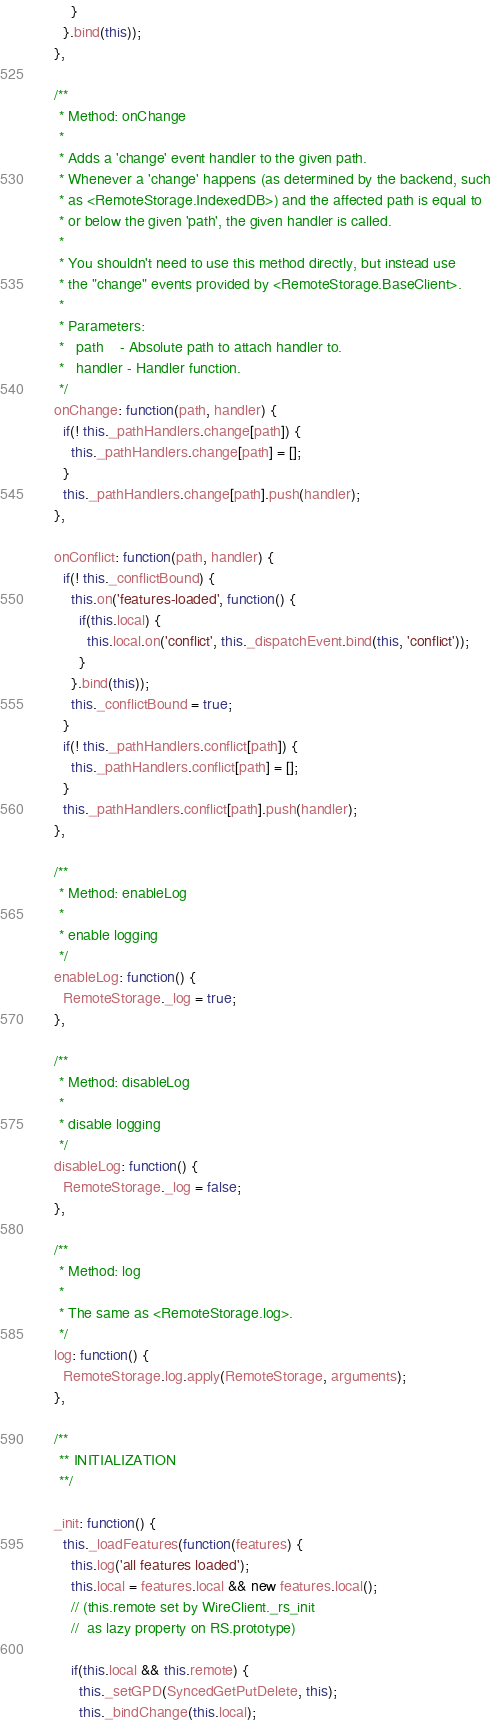Convert code to text. <code><loc_0><loc_0><loc_500><loc_500><_JavaScript_>        }
      }.bind(this));
    },

    /**
     * Method: onChange
     *
     * Adds a 'change' event handler to the given path.
     * Whenever a 'change' happens (as determined by the backend, such
     * as <RemoteStorage.IndexedDB>) and the affected path is equal to
     * or below the given 'path', the given handler is called.
     *
     * You shouldn't need to use this method directly, but instead use
     * the "change" events provided by <RemoteStorage.BaseClient>.
     *
     * Parameters:
     *   path    - Absolute path to attach handler to.
     *   handler - Handler function.
     */
    onChange: function(path, handler) {
      if(! this._pathHandlers.change[path]) {
        this._pathHandlers.change[path] = [];
      }
      this._pathHandlers.change[path].push(handler);
    },

    onConflict: function(path, handler) {
      if(! this._conflictBound) {
        this.on('features-loaded', function() {
          if(this.local) {
            this.local.on('conflict', this._dispatchEvent.bind(this, 'conflict'));
          }
        }.bind(this));
        this._conflictBound = true;
      }
      if(! this._pathHandlers.conflict[path]) {
        this._pathHandlers.conflict[path] = [];
      }
      this._pathHandlers.conflict[path].push(handler);
    },

    /**
     * Method: enableLog
     *
     * enable logging
     */
    enableLog: function() {
      RemoteStorage._log = true;
    },

    /**
     * Method: disableLog
     *
     * disable logging
     */
    disableLog: function() {
      RemoteStorage._log = false;
    },

    /**
     * Method: log
     *
     * The same as <RemoteStorage.log>.
     */
    log: function() {
      RemoteStorage.log.apply(RemoteStorage, arguments);
    },

    /**
     ** INITIALIZATION
     **/

    _init: function() {
      this._loadFeatures(function(features) {
        this.log('all features loaded');
        this.local = features.local && new features.local();
        // (this.remote set by WireClient._rs_init
        //  as lazy property on RS.prototype)

        if(this.local && this.remote) {
          this._setGPD(SyncedGetPutDelete, this);
          this._bindChange(this.local);</code> 